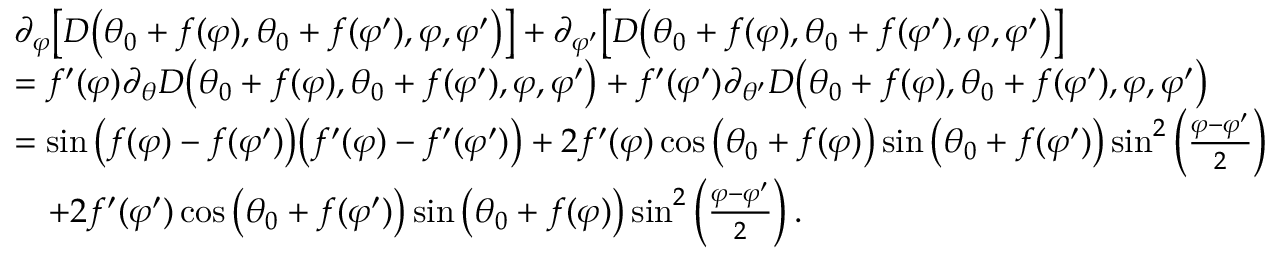<formula> <loc_0><loc_0><loc_500><loc_500>\begin{array} { r l } & { \partial _ { \varphi } \left [ D \left ( \theta _ { 0 } + f ( \varphi ) , \theta _ { 0 } + f ( \varphi ^ { \prime } ) , \varphi , \varphi ^ { \prime } \right ) \right ] + \partial _ { \varphi ^ { \prime } } \left [ D \left ( \theta _ { 0 } + f ( \varphi ) , \theta _ { 0 } + f ( \varphi ^ { \prime } ) , \varphi , \varphi ^ { \prime } \right ) \right ] } \\ & { = f ^ { \prime } ( \varphi ) \partial _ { \theta } D \left ( \theta _ { 0 } + f ( \varphi ) , \theta _ { 0 } + f ( \varphi ^ { \prime } ) , \varphi , \varphi ^ { \prime } \right ) + f ^ { \prime } ( \varphi ^ { \prime } ) \partial _ { \theta ^ { \prime } } D \left ( \theta _ { 0 } + f ( \varphi ) , \theta _ { 0 } + f ( \varphi ^ { \prime } ) , \varphi , \varphi ^ { \prime } \right ) } \\ & { = \sin \left ( f ( \varphi ) - f ( \varphi ^ { \prime } ) \right ) \left ( f ^ { \prime } ( \varphi ) - f ^ { \prime } ( \varphi ^ { \prime } ) \right ) + 2 f ^ { \prime } ( \varphi ) \cos \left ( \theta _ { 0 } + f ( \varphi ) \right ) \sin \left ( \theta _ { 0 } + f ( \varphi ^ { \prime } ) \right ) \sin ^ { 2 } \left ( \frac { \varphi - \varphi ^ { \prime } } { 2 } \right ) } \\ & { \quad + 2 f ^ { \prime } ( \varphi ^ { \prime } ) \cos \left ( \theta _ { 0 } + f ( \varphi ^ { \prime } ) \right ) \sin \left ( \theta _ { 0 } + f ( \varphi ) \right ) \sin ^ { 2 } \left ( \frac { \varphi - \varphi ^ { \prime } } { 2 } \right ) . } \end{array}</formula> 